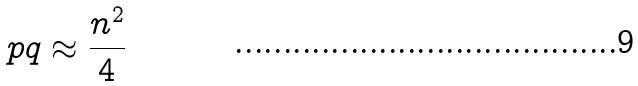Convert formula to latex. <formula><loc_0><loc_0><loc_500><loc_500>p q \approx \frac { n ^ { 2 } } { 4 }</formula> 